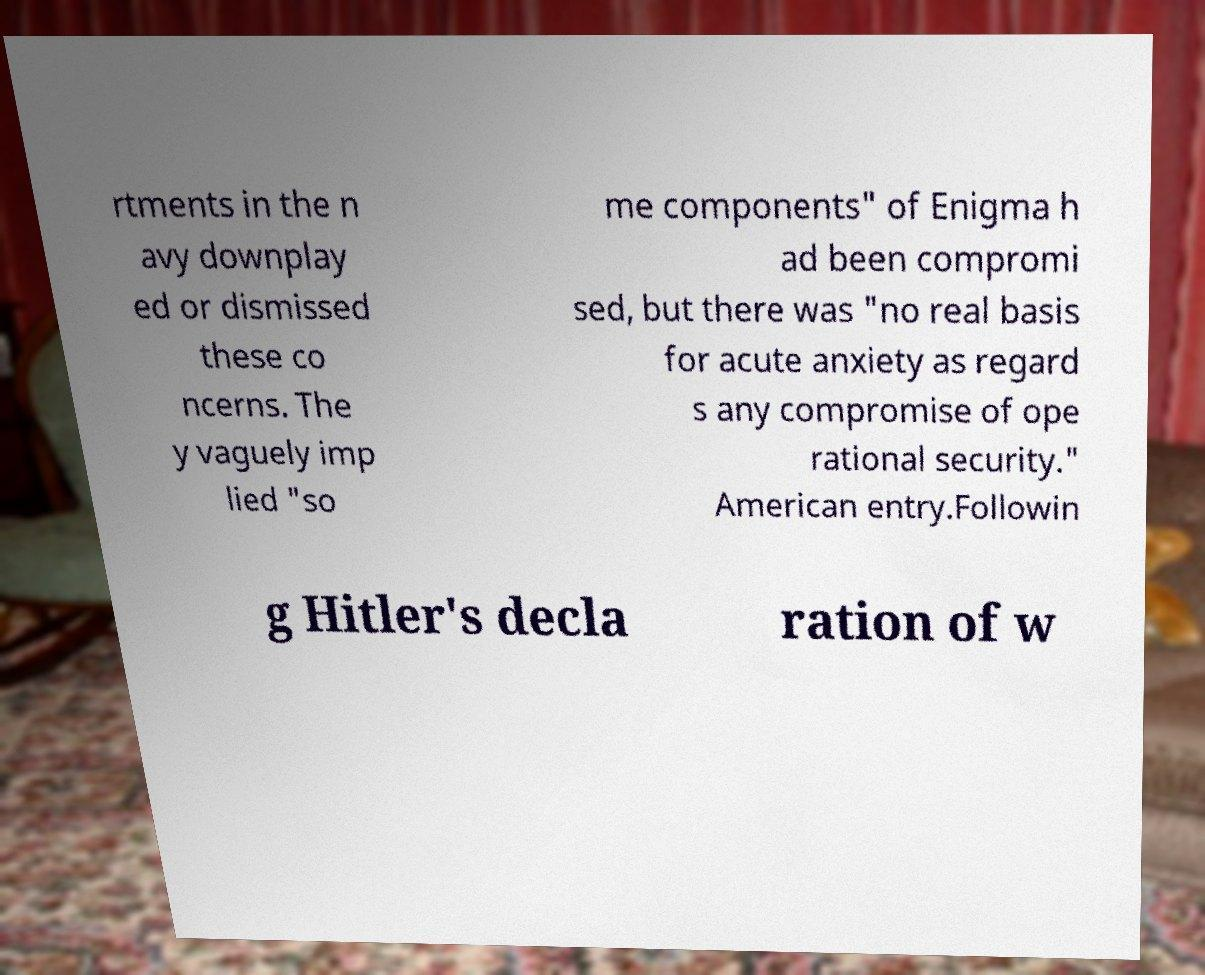Could you extract and type out the text from this image? rtments in the n avy downplay ed or dismissed these co ncerns. The y vaguely imp lied "so me components" of Enigma h ad been compromi sed, but there was "no real basis for acute anxiety as regard s any compromise of ope rational security." American entry.Followin g Hitler's decla ration of w 